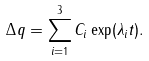Convert formula to latex. <formula><loc_0><loc_0><loc_500><loc_500>\Delta q = \sum _ { i = 1 } ^ { 3 } C _ { i } \exp ( \lambda _ { i } t ) .</formula> 